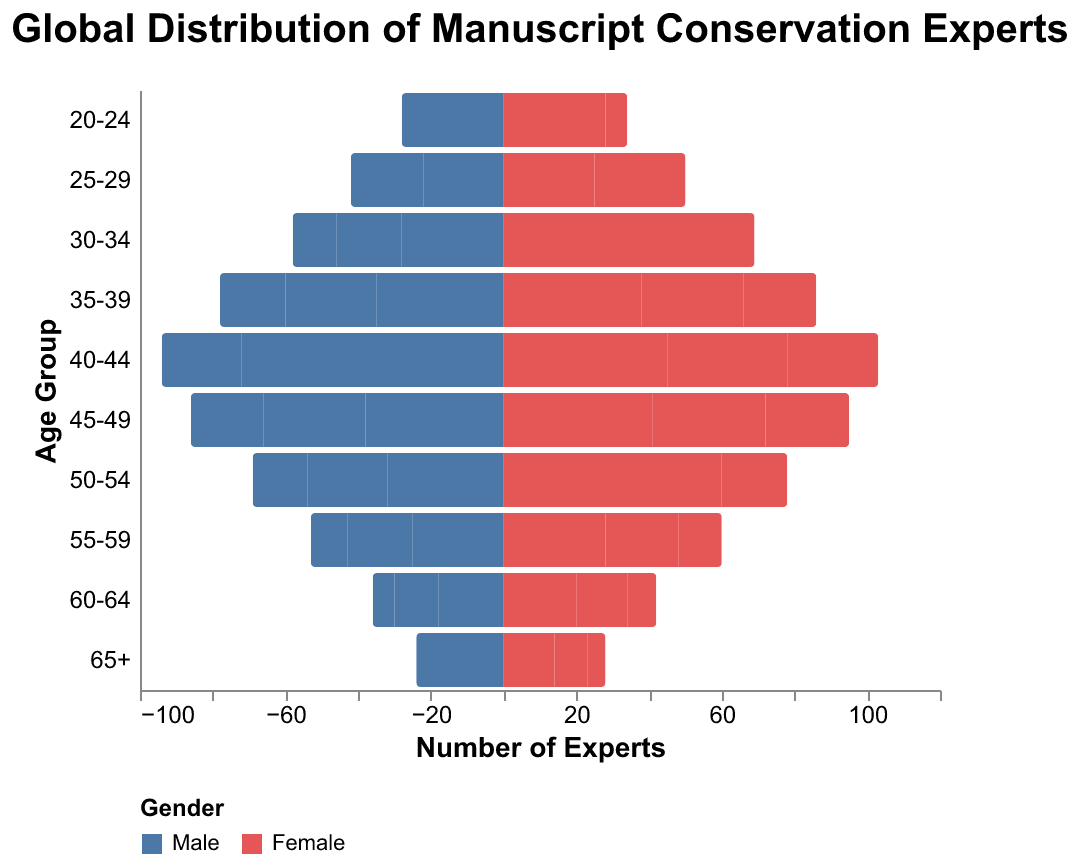What is the title of the figure? The title of a figure is typically located at the top and it provides a brief description of the visualized data. In this case, the title should summarize the topic of the figure.
Answer: Global Distribution of Manuscript Conservation Experts Which gender has a higher number of experts in the 30-34 age group in Europe? To answer this, identify the "Europe" column, find the 30-34 age group, and compare the heights of the bars for Male and Female.
Answer: Female How many total experts (both genders) are there in the 40-44 age group in North America? Add the number of male experts and female experts in the 40-44 age group from the North America column. The values are 30 for males and 33 for females. The sum is 30 + 33.
Answer: 63 Which region has the highest number of male experts in the 35-39 age group? Compare the height of the Male bars for the 35-39 age group across different regions. The values are 35 (Europe), 25 (North America), and 18 (Asia).
Answer: Europe What is the total number of female experts in Asia across all age groups? Sum the number of female experts for each age group in the Asia column. Add up 6 + 10 + 15 + 20 + 25 + 23 + 18 + 12 + 8 + 5.
Answer: 142 How does the population of female experts in the 50-54 age group compare between Europe and Asia? Compare the height of the Female bars for the 50-54 age group between Europe (35) and Asia (18).
Answer: Europe has more female experts What is the average number of male experts across all age groups in North America? Calculate the average by summing the number of male experts in all age groups in the North America column and then divide by the number of age groups. Sum is 8 + 12 + 18 + 25 + 30 + 28 + 22 + 18 + 12 + 8 = 181. There are 10 age groups, so the average is 181/10.
Answer: 18.1 Which age group has the smallest number of experts in Asia? Identify the age group in Asia with the smallest sums of Male and Female bars. The values are smallest in the 65+ age bracket (4 males and 5 females).
Answer: 65+ Are there more male or female experts in Europe in the 45-49 age group? Compare the number of male and female experts in the 45-49 age group for Europe. The values are 38 (male) and 41 (female).
Answer: Female 